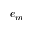Convert formula to latex. <formula><loc_0><loc_0><loc_500><loc_500>e _ { m }</formula> 